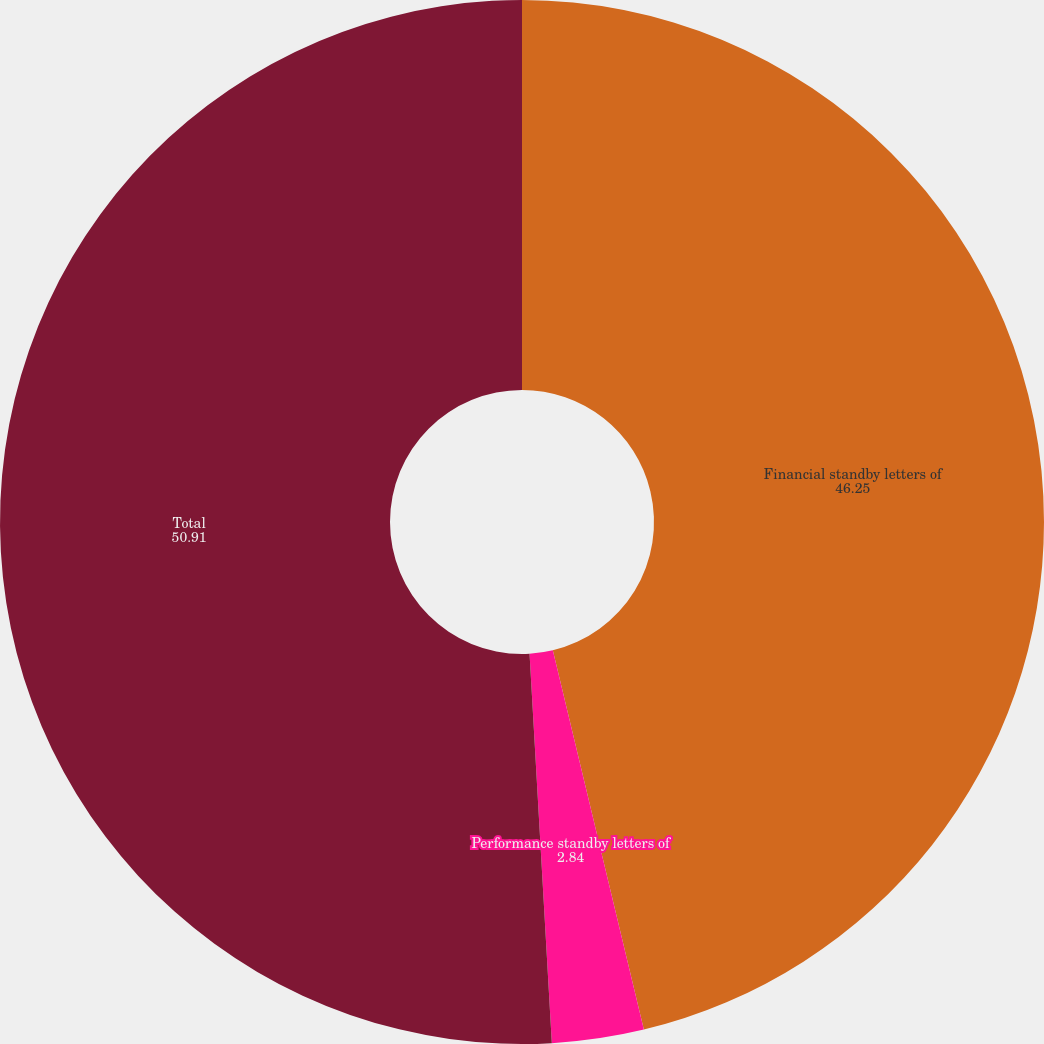Convert chart to OTSL. <chart><loc_0><loc_0><loc_500><loc_500><pie_chart><fcel>Financial standby letters of<fcel>Performance standby letters of<fcel>Total<nl><fcel>46.25%<fcel>2.84%<fcel>50.91%<nl></chart> 